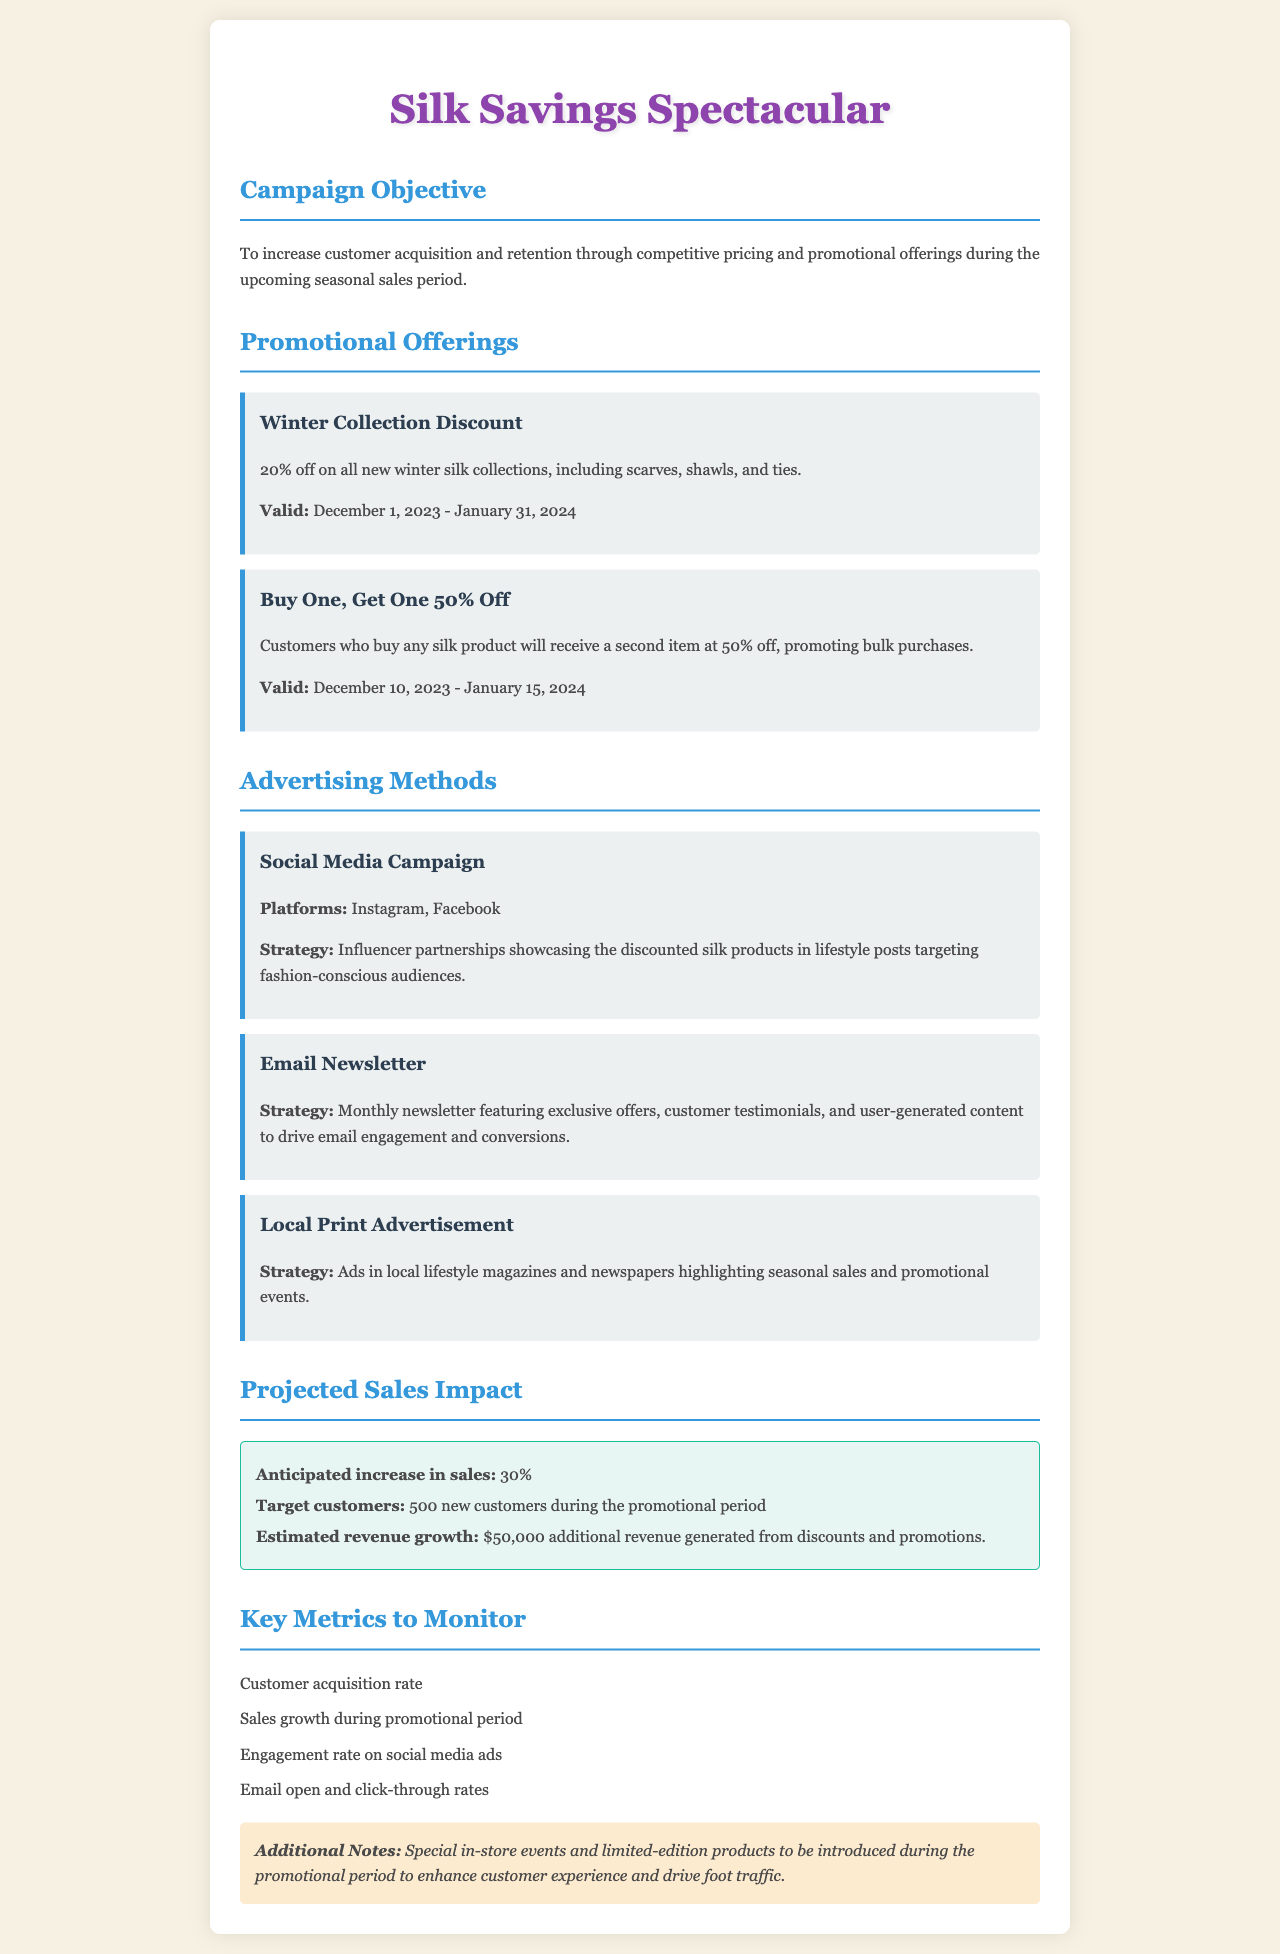What is the promotional offering for the winter collection? The document states a discount of 20% off on all new winter silk collections.
Answer: 20% off When is the validity period for the Buy One, Get One 50% Off offer? The validity period for this promotional offer is from December 10, 2023 to January 15, 2024.
Answer: December 10, 2023 - January 15, 2024 Which social media platforms are included in the advertising methods? The document lists Instagram and Facebook as the platforms for the social media campaign.
Answer: Instagram, Facebook What is the anticipated increase in sales projected by the campaign? The anticipated increase in sales mentioned in the document is 30%.
Answer: 30% How many new customers does the campaign aim to attract? The document states that the target is to acquire 500 new customers during the promotional period.
Answer: 500 What type of advertising strategy is mentioned in the Local Print Advertisement section? The strategy for local print advertisements is to highlight seasonal sales and promotional events in ads.
Answer: Highlighting seasonal sales and promotional events What is a key metric to monitor regarding customer engagement? The document lists engagement rate on social media ads as a key metric to monitor.
Answer: Engagement rate on social media ads What type of special events does the campaign plan to include? The document mentions special in-store events to enhance customer experience.
Answer: Special in-store events What is the estimated revenue growth from discounts and promotions? The estimated revenue growth stated in the document is $50,000 additional revenue.
Answer: $50,000 